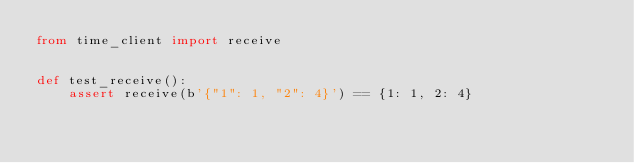Convert code to text. <code><loc_0><loc_0><loc_500><loc_500><_Python_>from time_client import receive


def test_receive():
    assert receive(b'{"1": 1, "2": 4}') == {1: 1, 2: 4}</code> 